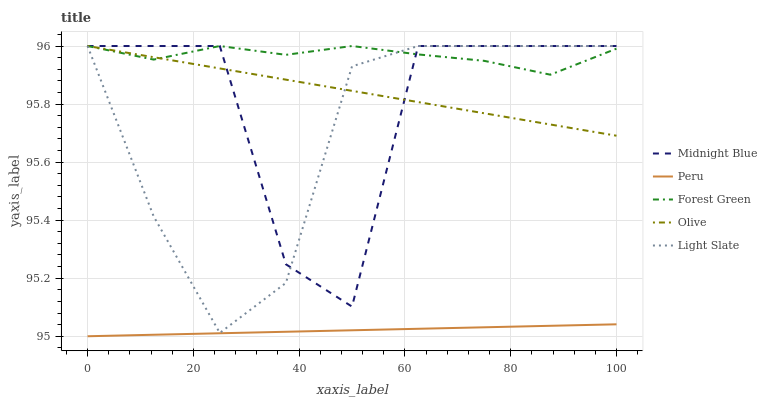Does Peru have the minimum area under the curve?
Answer yes or no. Yes. Does Forest Green have the maximum area under the curve?
Answer yes or no. Yes. Does Light Slate have the minimum area under the curve?
Answer yes or no. No. Does Light Slate have the maximum area under the curve?
Answer yes or no. No. Is Olive the smoothest?
Answer yes or no. Yes. Is Midnight Blue the roughest?
Answer yes or no. Yes. Is Light Slate the smoothest?
Answer yes or no. No. Is Light Slate the roughest?
Answer yes or no. No. Does Peru have the lowest value?
Answer yes or no. Yes. Does Light Slate have the lowest value?
Answer yes or no. No. Does Midnight Blue have the highest value?
Answer yes or no. Yes. Does Peru have the highest value?
Answer yes or no. No. Is Peru less than Forest Green?
Answer yes or no. Yes. Is Midnight Blue greater than Peru?
Answer yes or no. Yes. Does Light Slate intersect Midnight Blue?
Answer yes or no. Yes. Is Light Slate less than Midnight Blue?
Answer yes or no. No. Is Light Slate greater than Midnight Blue?
Answer yes or no. No. Does Peru intersect Forest Green?
Answer yes or no. No. 